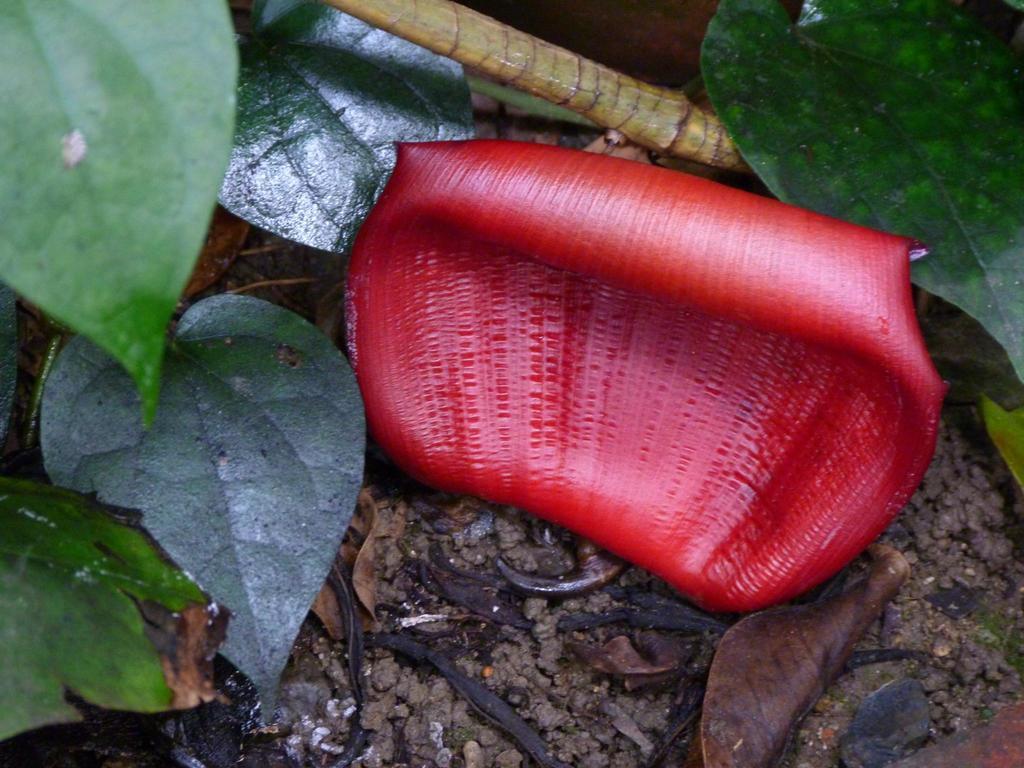Please provide a concise description of this image. In this image I can see some leaves and a petal of a flower and a stick on the ground. 